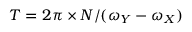Convert formula to latex. <formula><loc_0><loc_0><loc_500><loc_500>T = 2 \pi \times N / ( \omega _ { Y } - \omega _ { X } )</formula> 